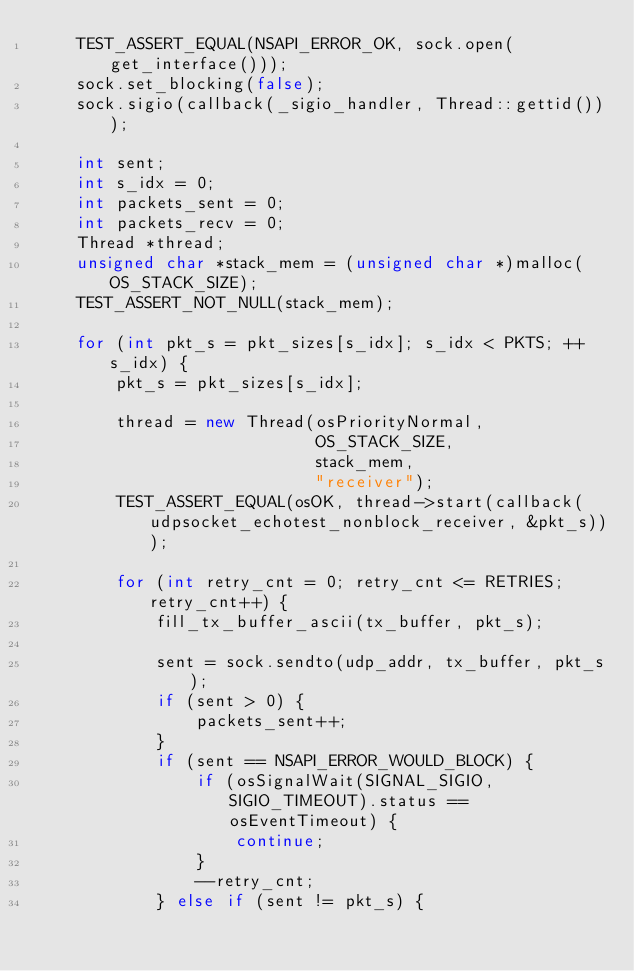<code> <loc_0><loc_0><loc_500><loc_500><_C++_>    TEST_ASSERT_EQUAL(NSAPI_ERROR_OK, sock.open(get_interface()));
    sock.set_blocking(false);
    sock.sigio(callback(_sigio_handler, Thread::gettid()));

    int sent;
    int s_idx = 0;
    int packets_sent = 0;
    int packets_recv = 0;
    Thread *thread;
    unsigned char *stack_mem = (unsigned char *)malloc(OS_STACK_SIZE);
    TEST_ASSERT_NOT_NULL(stack_mem);

    for (int pkt_s = pkt_sizes[s_idx]; s_idx < PKTS; ++s_idx) {
        pkt_s = pkt_sizes[s_idx];

        thread = new Thread(osPriorityNormal,
                            OS_STACK_SIZE,
                            stack_mem,
                            "receiver");
        TEST_ASSERT_EQUAL(osOK, thread->start(callback(udpsocket_echotest_nonblock_receiver, &pkt_s)));

        for (int retry_cnt = 0; retry_cnt <= RETRIES; retry_cnt++) {
            fill_tx_buffer_ascii(tx_buffer, pkt_s);

            sent = sock.sendto(udp_addr, tx_buffer, pkt_s);
            if (sent > 0) {
                packets_sent++;
            }
            if (sent == NSAPI_ERROR_WOULD_BLOCK) {
                if (osSignalWait(SIGNAL_SIGIO, SIGIO_TIMEOUT).status == osEventTimeout) {
                    continue;
                }
                --retry_cnt;
            } else if (sent != pkt_s) {</code> 